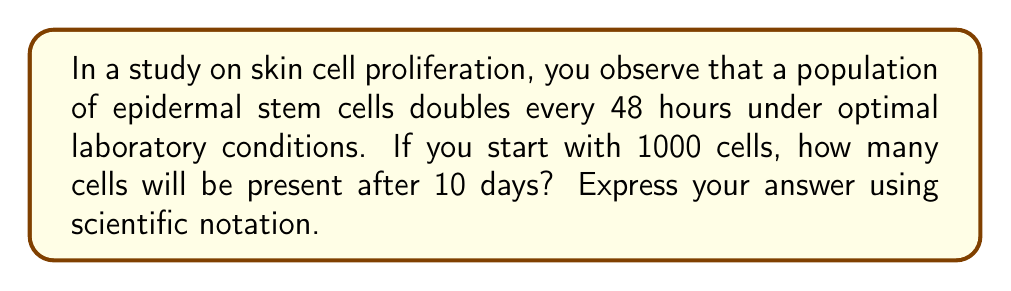Give your solution to this math problem. To solve this problem, we'll use the exponential growth formula:

$$A = P(1 + r)^t$$

Where:
$A$ = Final amount
$P$ = Initial amount (1000 cells)
$r$ = Growth rate per unit time
$t$ = Number of time units

1. First, we need to determine the growth rate and time units:
   - The population doubles every 48 hours, so $r = 1$ (100% growth) per 2 days.
   - 10 days = 5 periods of 48 hours

2. Now we can set up our equation:
   $$A = 1000(1 + 1)^5$$

3. Simplify:
   $$A = 1000(2)^5$$

4. Calculate:
   $$A = 1000 \times 32 = 32,000$$

5. Express in scientific notation:
   $$A = 3.2 \times 10^4$$
Answer: $3.2 \times 10^4$ cells 